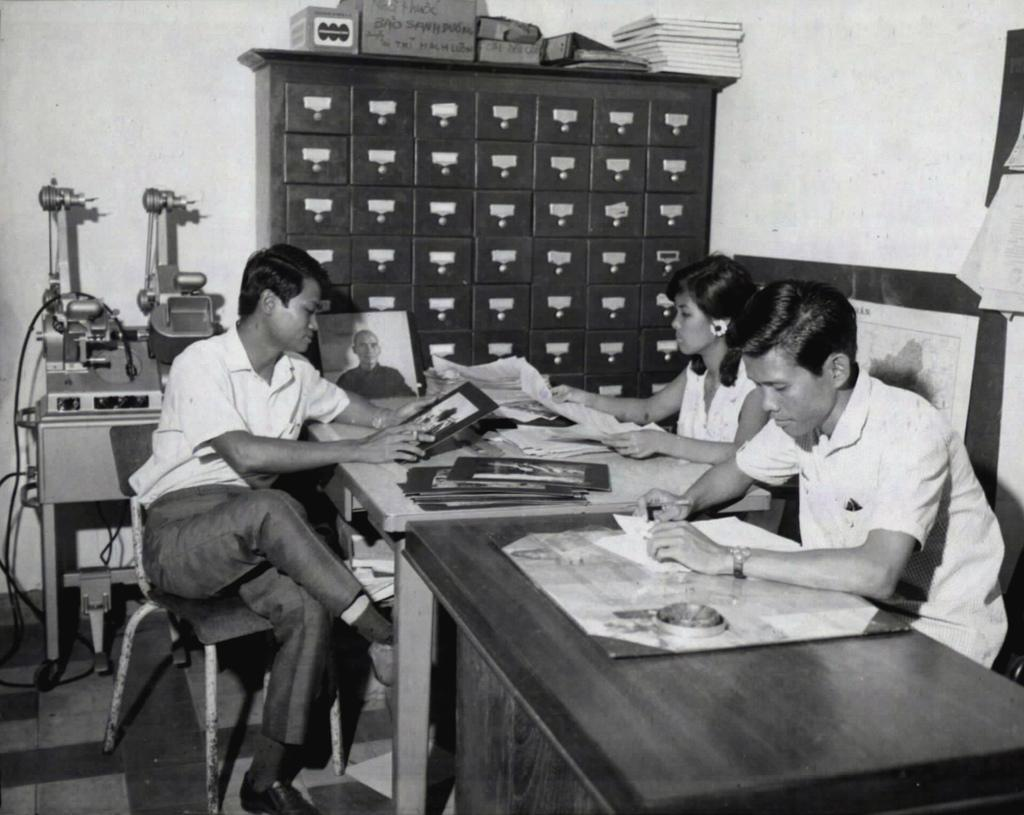What are the people in the image doing? The people in the image are sitting around a table. What are the people holding in the image? The people are holding a paper. What type of furniture can be seen in the room? There are lockers in the room. What else can be seen in the room? There are machines in the corner of the room. What type of stocking is being used to hold the account in the image? There is no stocking or account present in the image. 